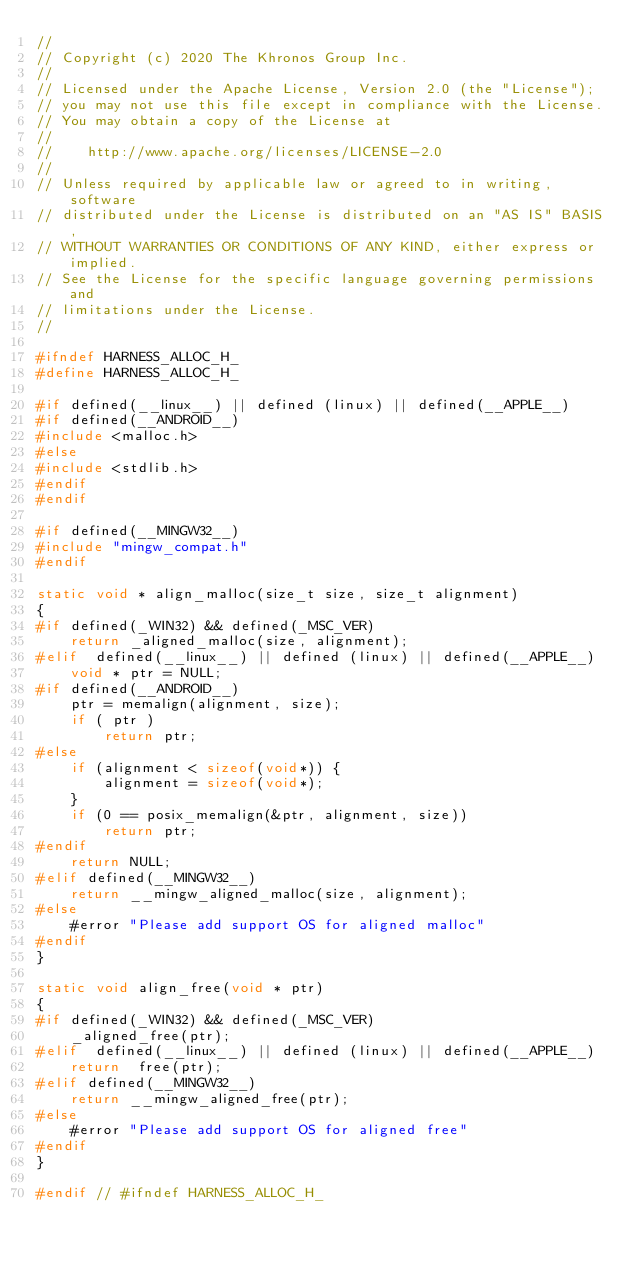<code> <loc_0><loc_0><loc_500><loc_500><_C_>//
// Copyright (c) 2020 The Khronos Group Inc.
//
// Licensed under the Apache License, Version 2.0 (the "License");
// you may not use this file except in compliance with the License.
// You may obtain a copy of the License at
//
//    http://www.apache.org/licenses/LICENSE-2.0
//
// Unless required by applicable law or agreed to in writing, software
// distributed under the License is distributed on an "AS IS" BASIS,
// WITHOUT WARRANTIES OR CONDITIONS OF ANY KIND, either express or implied.
// See the License for the specific language governing permissions and
// limitations under the License.
//

#ifndef HARNESS_ALLOC_H_
#define HARNESS_ALLOC_H_

#if defined(__linux__) || defined (linux) || defined(__APPLE__)
#if defined(__ANDROID__)
#include <malloc.h>
#else
#include <stdlib.h>
#endif
#endif

#if defined(__MINGW32__)
#include "mingw_compat.h"
#endif

static void * align_malloc(size_t size, size_t alignment)
{
#if defined(_WIN32) && defined(_MSC_VER)
    return _aligned_malloc(size, alignment);
#elif  defined(__linux__) || defined (linux) || defined(__APPLE__)
    void * ptr = NULL;
#if defined(__ANDROID__)
    ptr = memalign(alignment, size);
    if ( ptr )
        return ptr;
#else
    if (alignment < sizeof(void*)) {
        alignment = sizeof(void*);
    }
    if (0 == posix_memalign(&ptr, alignment, size))
        return ptr;
#endif
    return NULL;
#elif defined(__MINGW32__)
    return __mingw_aligned_malloc(size, alignment);
#else
    #error "Please add support OS for aligned malloc"
#endif
}

static void align_free(void * ptr)
{
#if defined(_WIN32) && defined(_MSC_VER)
    _aligned_free(ptr);
#elif  defined(__linux__) || defined (linux) || defined(__APPLE__)
    return  free(ptr);
#elif defined(__MINGW32__)
    return __mingw_aligned_free(ptr);
#else
    #error "Please add support OS for aligned free"
#endif
}

#endif // #ifndef HARNESS_ALLOC_H_

</code> 